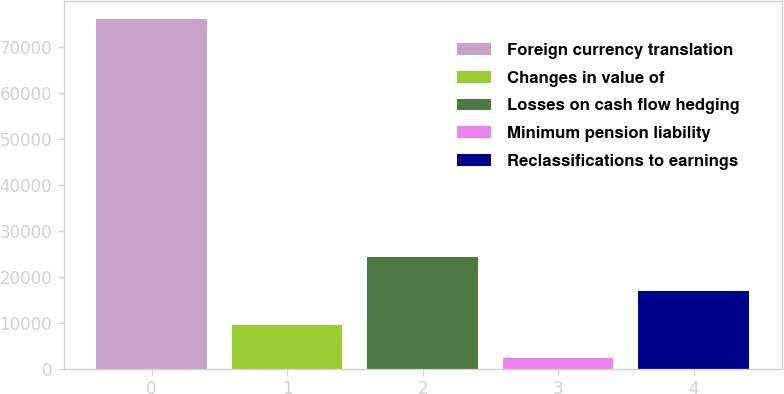Convert chart. <chart><loc_0><loc_0><loc_500><loc_500><bar_chart><fcel>Foreign currency translation<fcel>Changes in value of<fcel>Losses on cash flow hedging<fcel>Minimum pension liability<fcel>Reclassifications to earnings<nl><fcel>76126<fcel>9580.9<fcel>24368.7<fcel>2187<fcel>16974.8<nl></chart> 